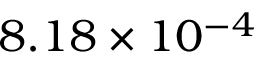<formula> <loc_0><loc_0><loc_500><loc_500>8 . 1 8 \times 1 0 ^ { - 4 }</formula> 